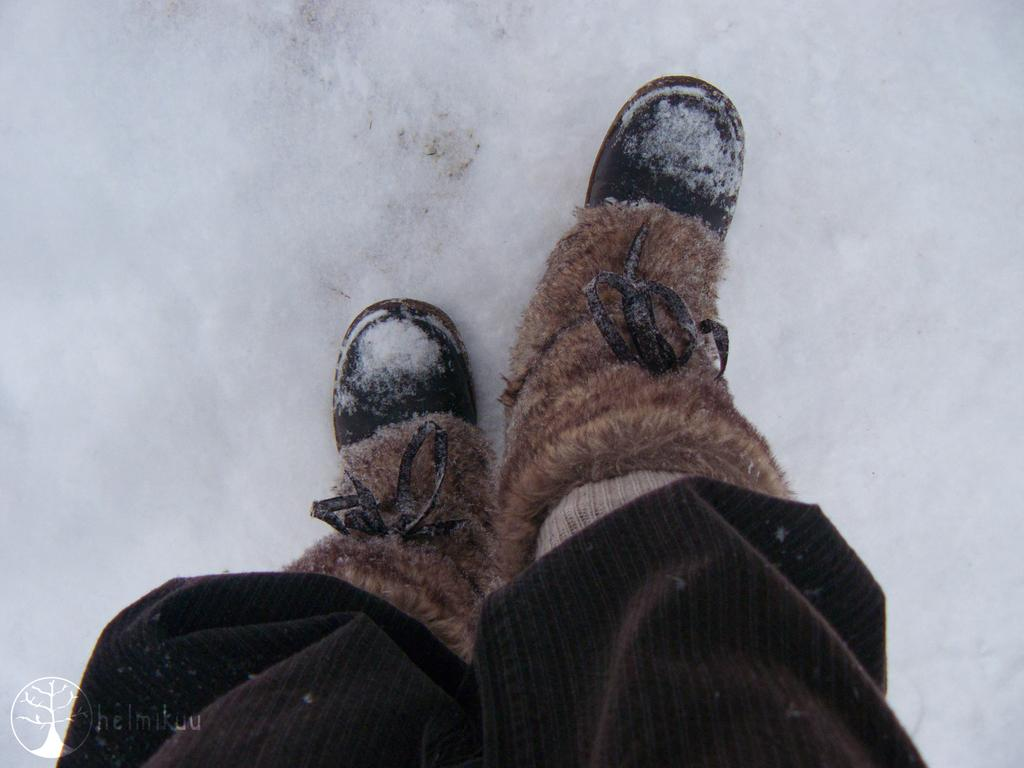What body part is visible in the image? There are person's legs in the image. What type of weather or environment is suggested by the background of the image? There is snow in the background of the image, suggesting a cold or wintry environment. What type of snake can be seen slithering through the snow in the image? There is no snake present in the image; it only features a person's legs and snow in the background. 